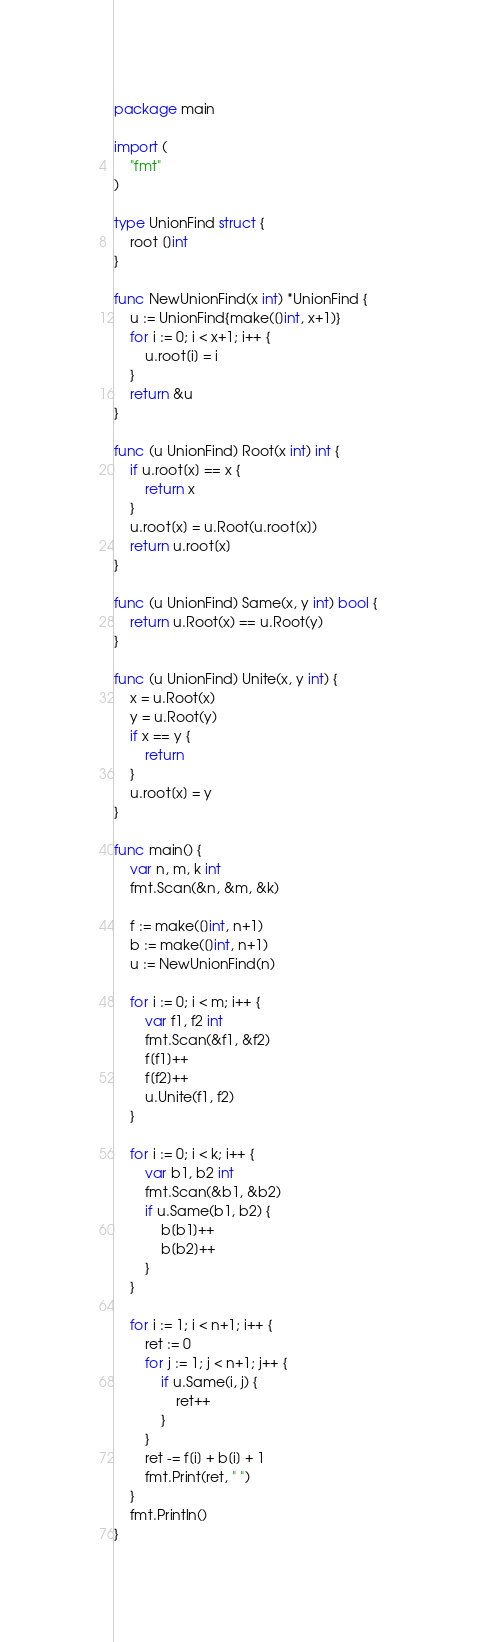<code> <loc_0><loc_0><loc_500><loc_500><_Go_>package main

import (
	"fmt"
)

type UnionFind struct {
	root []int
}

func NewUnionFind(x int) *UnionFind {
	u := UnionFind{make([]int, x+1)}
	for i := 0; i < x+1; i++ {
		u.root[i] = i
	}
	return &u
}

func (u UnionFind) Root(x int) int {
	if u.root[x] == x {
		return x
	}
	u.root[x] = u.Root(u.root[x])
	return u.root[x]
}

func (u UnionFind) Same(x, y int) bool {
	return u.Root(x) == u.Root(y)
}

func (u UnionFind) Unite(x, y int) {
	x = u.Root(x)
	y = u.Root(y)
	if x == y {
		return
	}
	u.root[x] = y
}

func main() {
	var n, m, k int
	fmt.Scan(&n, &m, &k)

	f := make([]int, n+1)
	b := make([]int, n+1)
	u := NewUnionFind(n)

	for i := 0; i < m; i++ {
		var f1, f2 int
		fmt.Scan(&f1, &f2)
		f[f1]++
		f[f2]++
		u.Unite(f1, f2)
	}

	for i := 0; i < k; i++ {
		var b1, b2 int
		fmt.Scan(&b1, &b2)
		if u.Same(b1, b2) {
			b[b1]++
			b[b2]++
		}
	}

	for i := 1; i < n+1; i++ {
		ret := 0
		for j := 1; j < n+1; j++ {
			if u.Same(i, j) {
				ret++
			}
		}
		ret -= f[i] + b[i] + 1
		fmt.Print(ret, " ")
	}
	fmt.Println()
}
</code> 